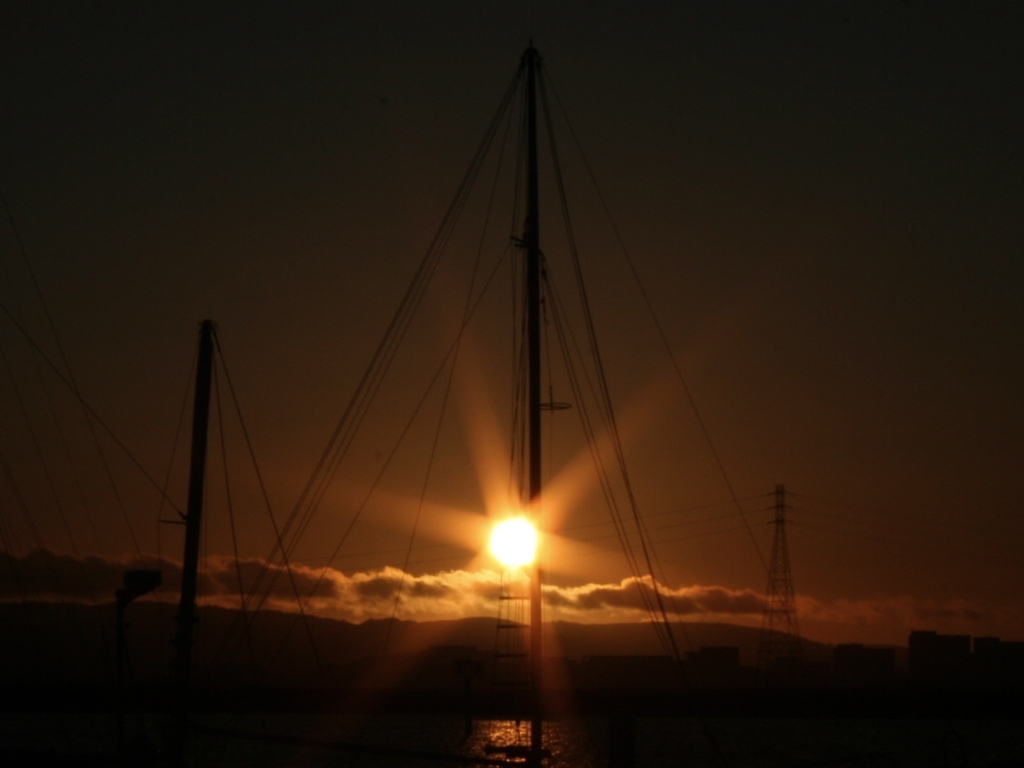Can you tell me what the weather looks like? The photo suggests that the weather is partly cloudy with clear visibility near the sun, hinting at a typical weather pattern during sunset where the clouds can be illuminated dramatically by the sun's rays. 